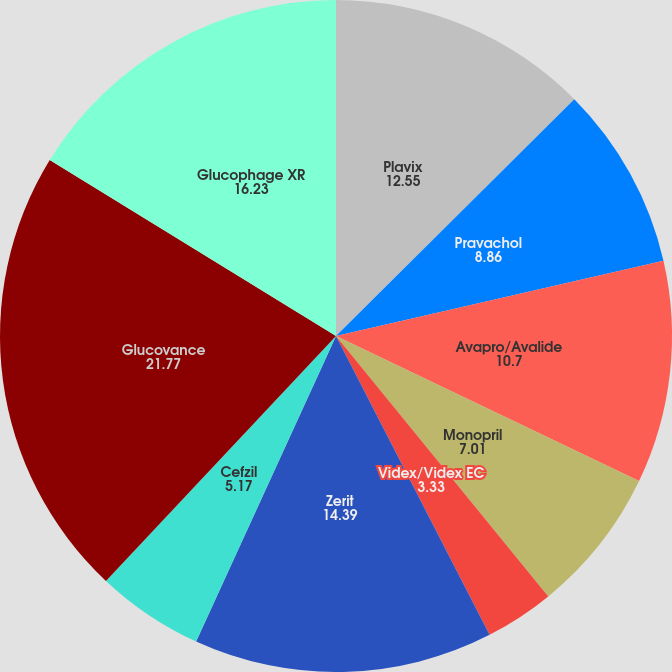Convert chart. <chart><loc_0><loc_0><loc_500><loc_500><pie_chart><fcel>Plavix<fcel>Pravachol<fcel>Avapro/Avalide<fcel>Monopril<fcel>Videx/Videx EC<fcel>Zerit<fcel>Cefzil<fcel>Glucovance<fcel>Glucophage XR<nl><fcel>12.55%<fcel>8.86%<fcel>10.7%<fcel>7.01%<fcel>3.33%<fcel>14.39%<fcel>5.17%<fcel>21.77%<fcel>16.23%<nl></chart> 